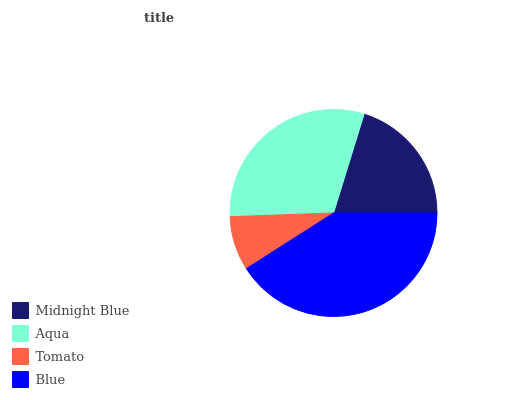Is Tomato the minimum?
Answer yes or no. Yes. Is Blue the maximum?
Answer yes or no. Yes. Is Aqua the minimum?
Answer yes or no. No. Is Aqua the maximum?
Answer yes or no. No. Is Aqua greater than Midnight Blue?
Answer yes or no. Yes. Is Midnight Blue less than Aqua?
Answer yes or no. Yes. Is Midnight Blue greater than Aqua?
Answer yes or no. No. Is Aqua less than Midnight Blue?
Answer yes or no. No. Is Aqua the high median?
Answer yes or no. Yes. Is Midnight Blue the low median?
Answer yes or no. Yes. Is Blue the high median?
Answer yes or no. No. Is Tomato the low median?
Answer yes or no. No. 